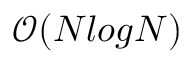Convert formula to latex. <formula><loc_0><loc_0><loc_500><loc_500>\mathcal { O } ( N \log N )</formula> 